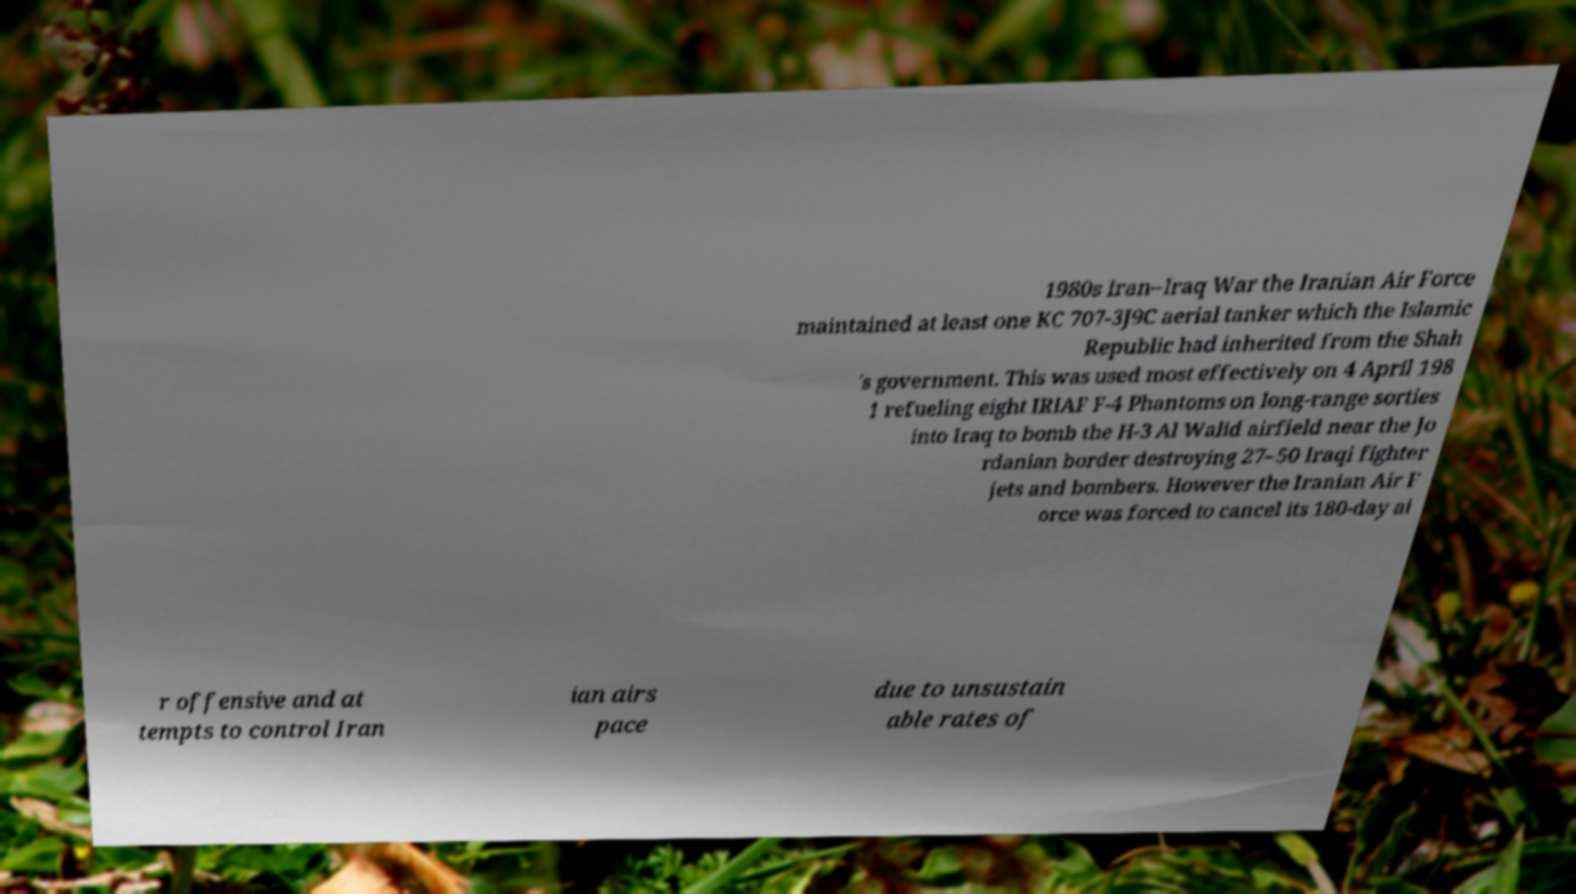For documentation purposes, I need the text within this image transcribed. Could you provide that? 1980s Iran–Iraq War the Iranian Air Force maintained at least one KC 707-3J9C aerial tanker which the Islamic Republic had inherited from the Shah 's government. This was used most effectively on 4 April 198 1 refueling eight IRIAF F-4 Phantoms on long-range sorties into Iraq to bomb the H-3 Al Walid airfield near the Jo rdanian border destroying 27–50 Iraqi fighter jets and bombers. However the Iranian Air F orce was forced to cancel its 180-day ai r offensive and at tempts to control Iran ian airs pace due to unsustain able rates of 